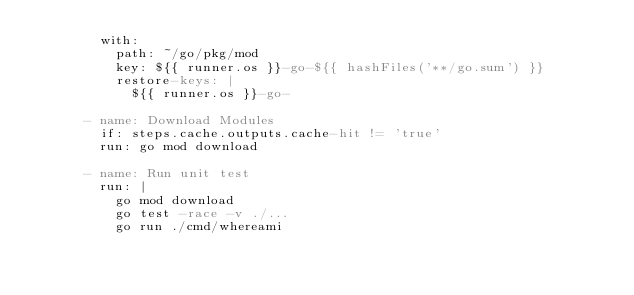Convert code to text. <code><loc_0><loc_0><loc_500><loc_500><_YAML_>        with:
          path: ~/go/pkg/mod
          key: ${{ runner.os }}-go-${{ hashFiles('**/go.sum') }}
          restore-keys: |
            ${{ runner.os }}-go-

      - name: Download Modules
        if: steps.cache.outputs.cache-hit != 'true'
        run: go mod download

      - name: Run unit test
        run: |
          go mod download
          go test -race -v ./...
          go run ./cmd/whereami
</code> 